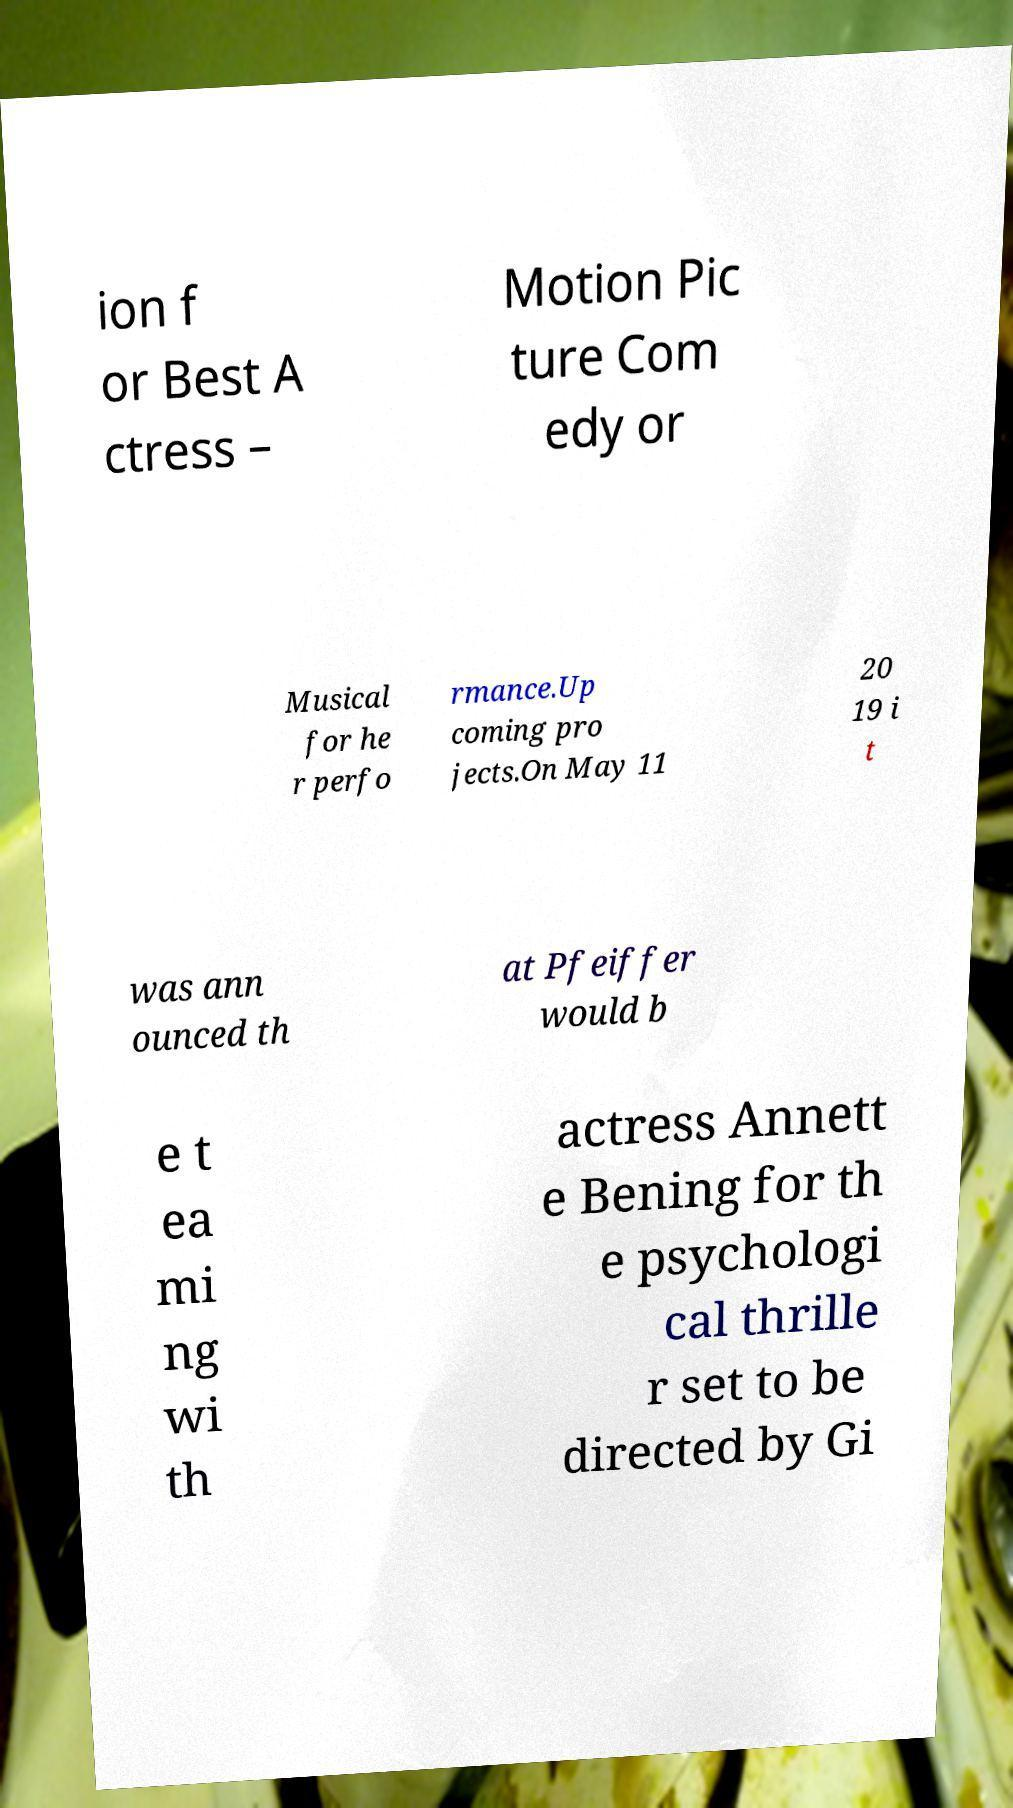Can you accurately transcribe the text from the provided image for me? ion f or Best A ctress – Motion Pic ture Com edy or Musical for he r perfo rmance.Up coming pro jects.On May 11 20 19 i t was ann ounced th at Pfeiffer would b e t ea mi ng wi th actress Annett e Bening for th e psychologi cal thrille r set to be directed by Gi 